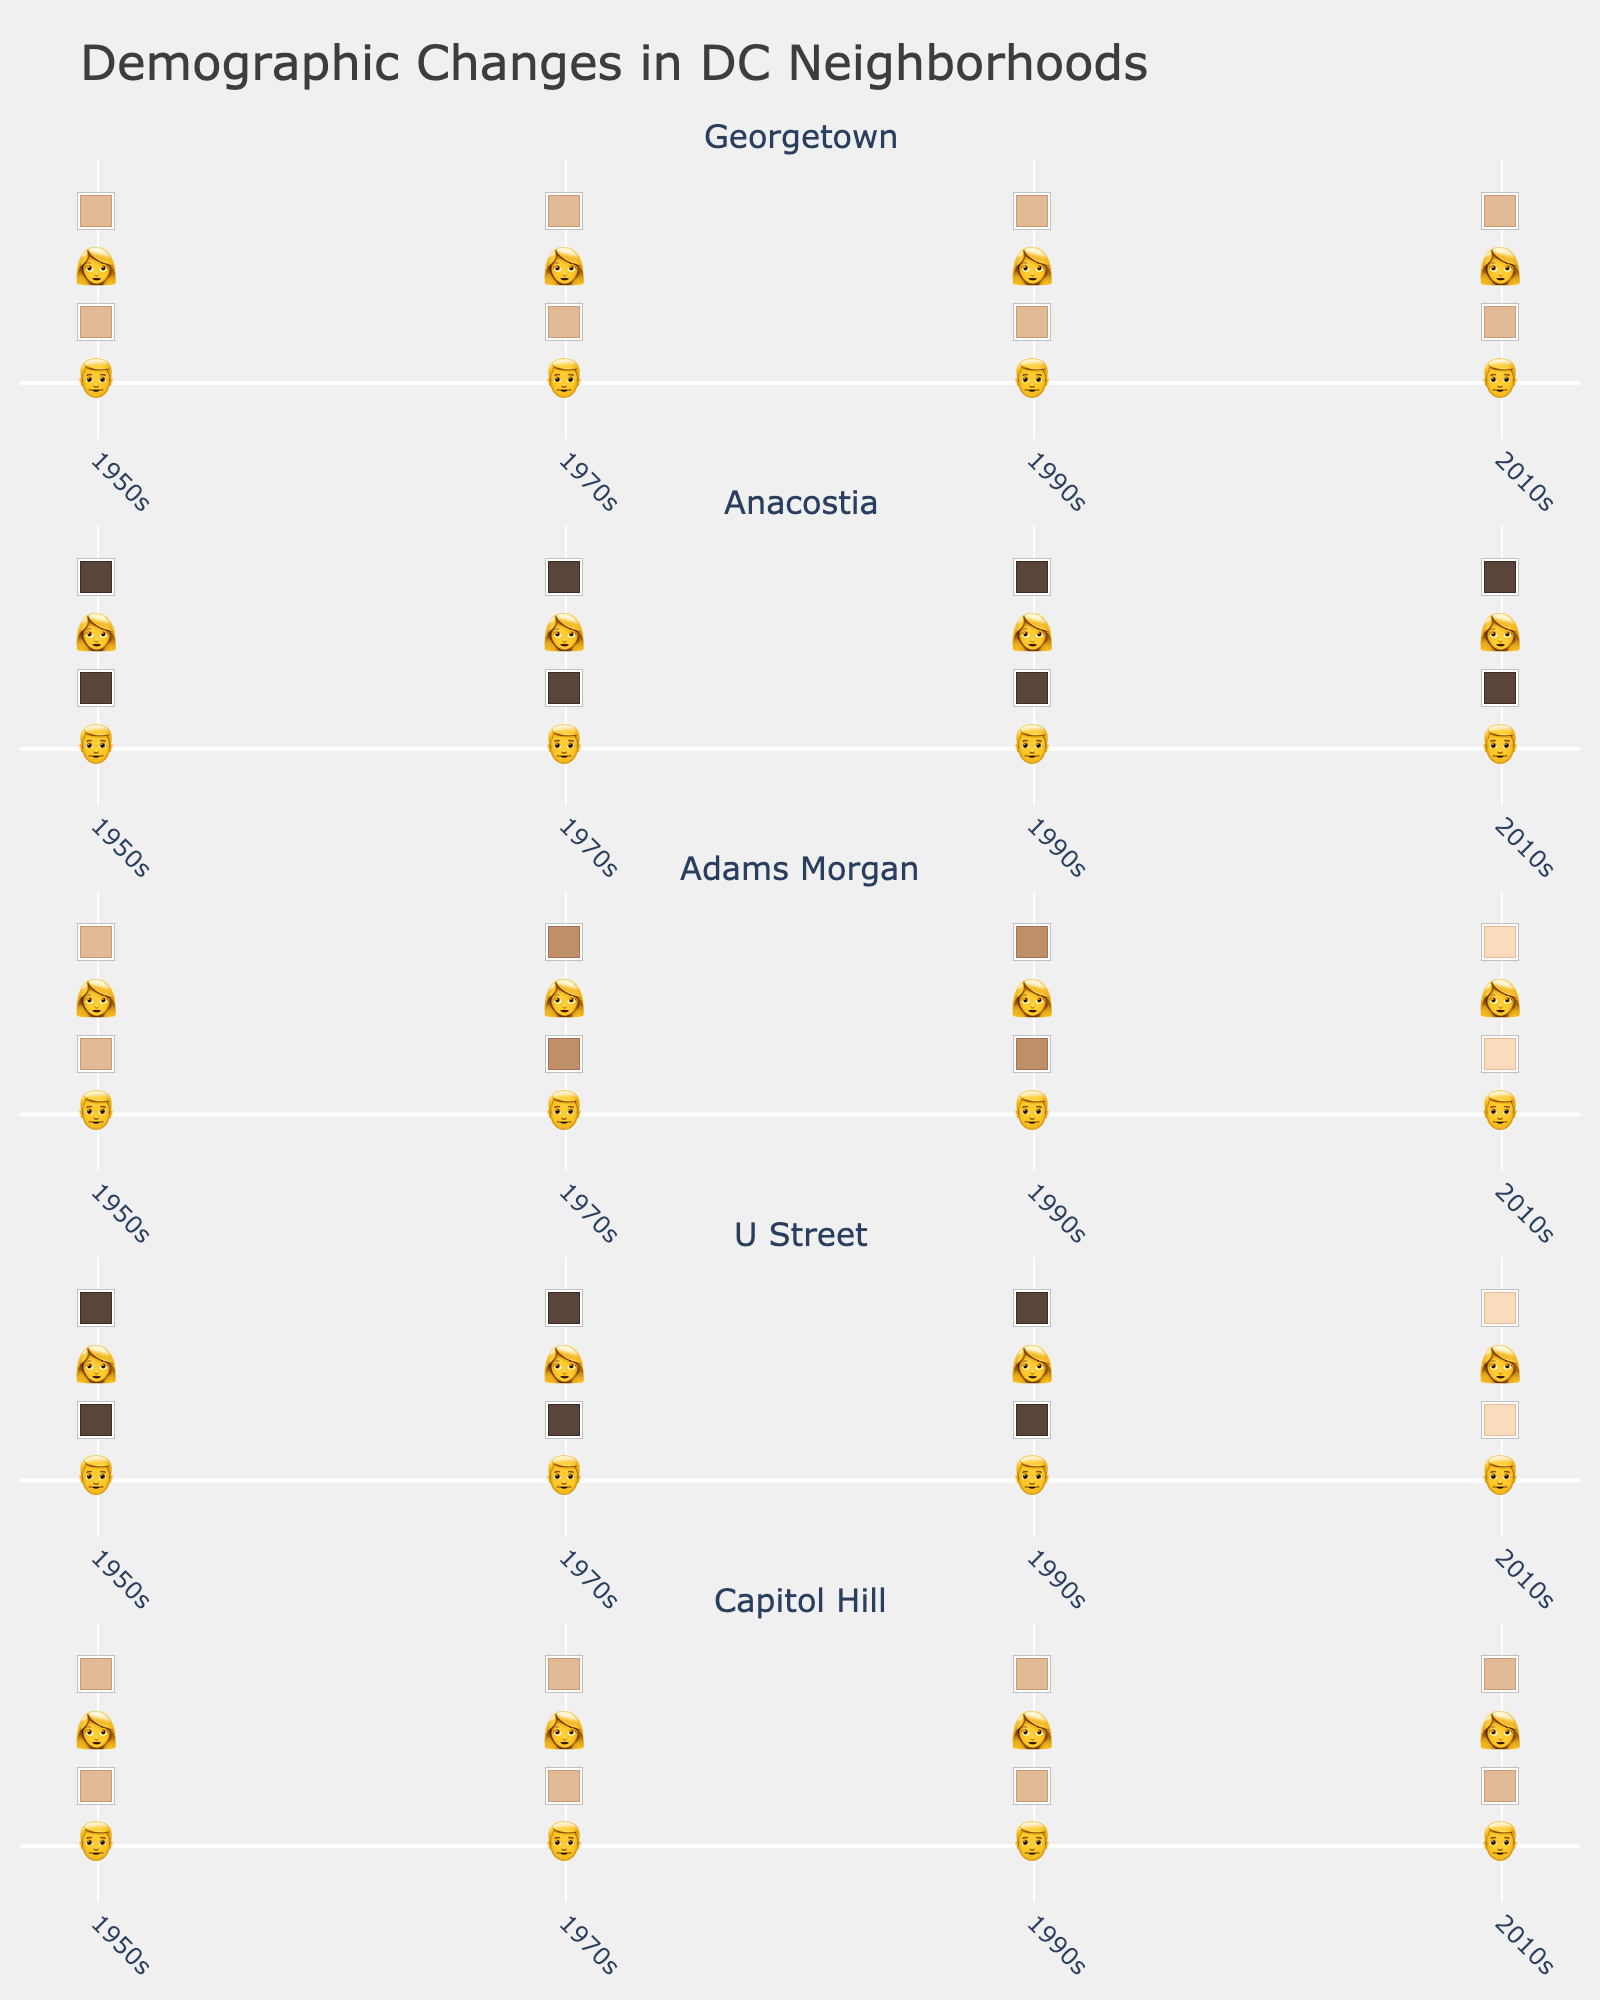What's the title of the figure? The title is displayed prominently at the top of the figure to describe what the figure is about.
Answer: Demographic Changes in DC Neighborhoods Which neighborhood shows the most consistent demographic representation from the 1950s to the 2010s? By examining the emojis for each neighborhood across the decades, Georgetown's demographics remain most consistent, with only slight changes.
Answer: Georgetown In Adams Morgan, which decades show a visible change in the demographic composition represented by the emojis? Looking at the emojis, there is a notable change between the 1950s and 1970s, and again between the 1990s and 2010s. The emojis change from light skin tones to darker skin tones and then to a mix of lighter tones.
Answer: 1950s to 1970s, 1990s to 2010s Compare the demographic diversity in U Street between the 1950s and 2010s. What stands out? In the 1950s, U Street had only black emojis. By the 2010s, there is a mix of lighter emojis indicating increased diversity over the decades.
Answer: Increased diversity in 2010s Which neighborhood shows the greatest demographic change between the 1990s and the 2010s? By comparing emojis, U Street shows a noticeable shift from predominantly black emojis in the 1990s to a mix of white and tan emojis in the 2010s.
Answer: U Street How did the demographic representation in Capitol Hill change in the 1970s compared to the 1950s? In the 1970s, there is the addition of black emojis, indicating a shift from a solely white demographic in the 1950s to a more diverse community.
Answer: More diverse in 1970s Which neighborhoods show the emergence of tan emojis by the 2010s? Checking the emojis for each neighborhood in the 2010s, Georgetown, Anacostia, Adams Morgan, U Street, and Capitol Hill all show the presence of tan emojis.
Answer: Georgetown, Anacostia, Adams Morgan, U Street, Capitol Hill Is there a neighborhood that remains predominantly black from the 1950s to the 2010s? By reviewing the emojis across all decades, Anacostia consistently shows black emojis, with some addition of tan emojis later.
Answer: Anacostia What's a notable visual pattern in the demographic shift in Adams Morgan over the decades? Adams Morgan shows a repeated cycle of changing demographics with the presence of different skin tone emojis in each era, unlike the stable patterns in some other neighborhoods.
Answer: Repeated cycle of demographic change 